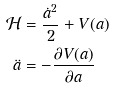<formula> <loc_0><loc_0><loc_500><loc_500>\mathcal { H } & = \frac { \dot { a } ^ { 2 } } { 2 } + V ( a ) \\ \ddot { a } & = - \frac { \partial V ( a ) } { \partial a }</formula> 